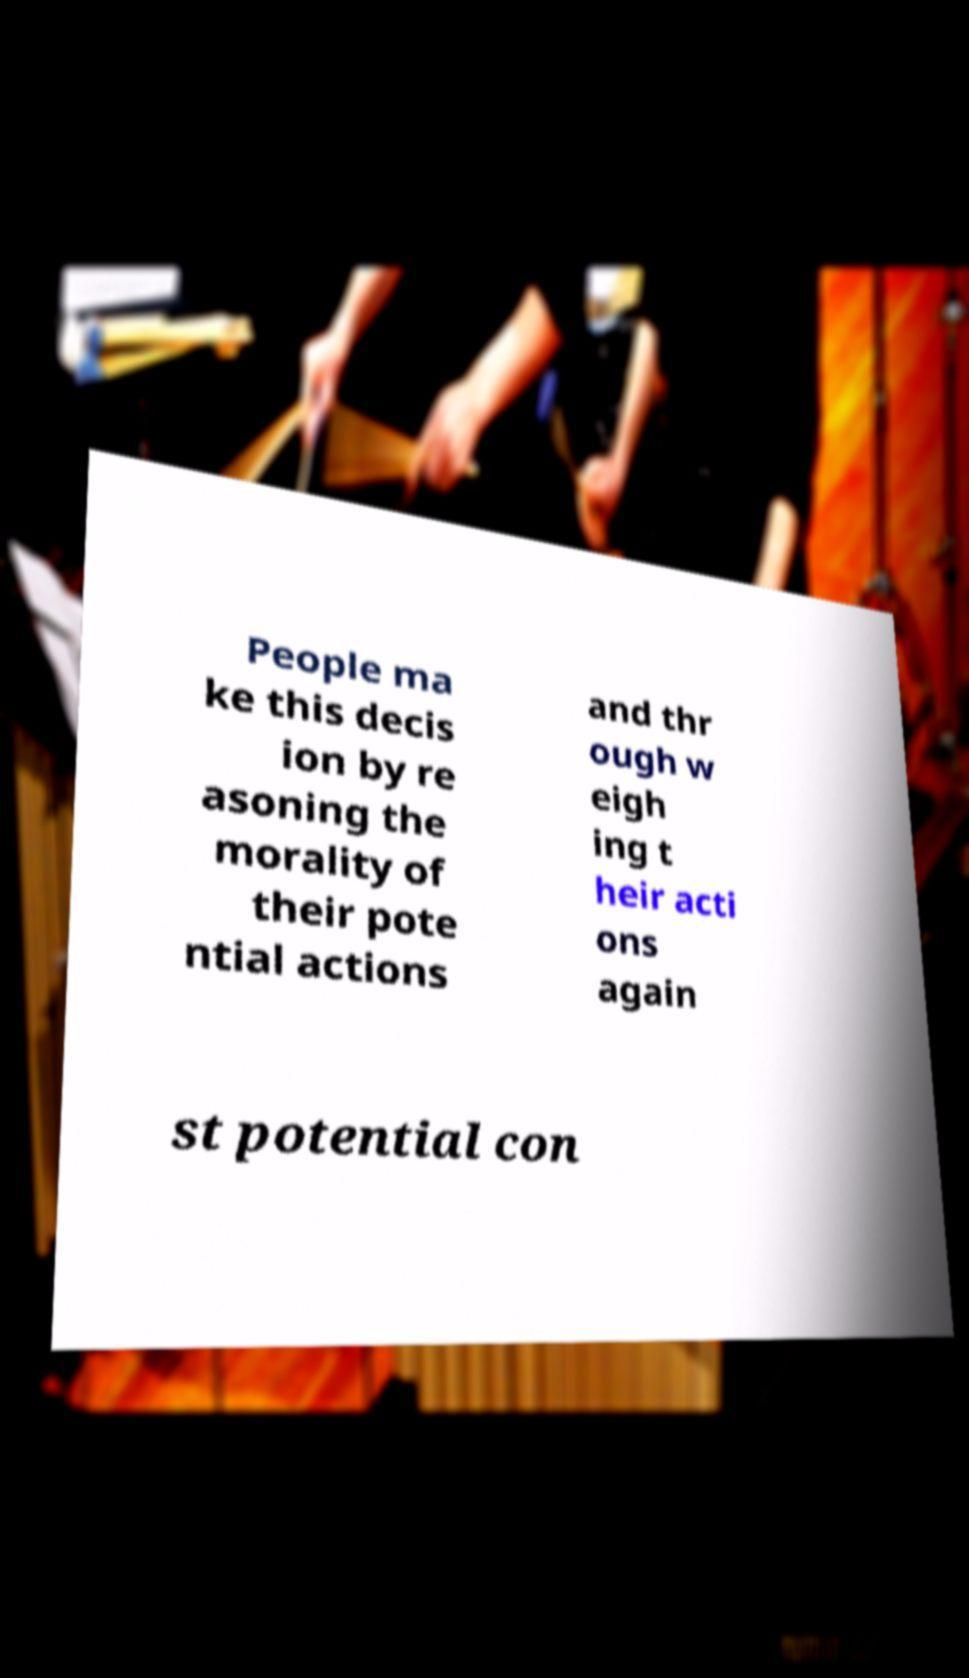Can you read and provide the text displayed in the image?This photo seems to have some interesting text. Can you extract and type it out for me? People ma ke this decis ion by re asoning the morality of their pote ntial actions and thr ough w eigh ing t heir acti ons again st potential con 